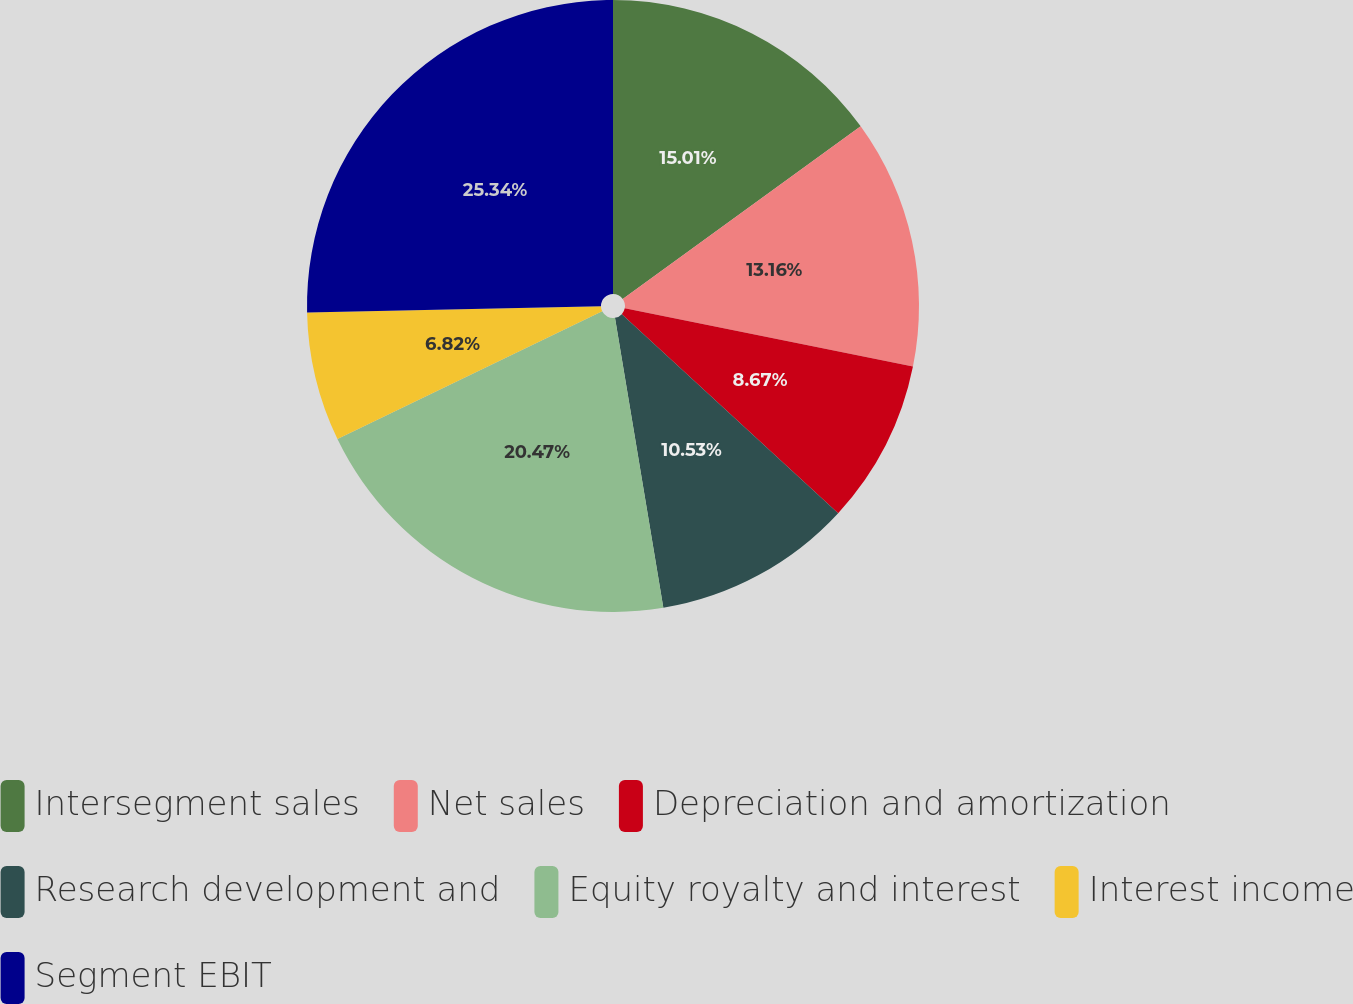Convert chart to OTSL. <chart><loc_0><loc_0><loc_500><loc_500><pie_chart><fcel>Intersegment sales<fcel>Net sales<fcel>Depreciation and amortization<fcel>Research development and<fcel>Equity royalty and interest<fcel>Interest income<fcel>Segment EBIT<nl><fcel>15.01%<fcel>13.16%<fcel>8.67%<fcel>10.53%<fcel>20.47%<fcel>6.82%<fcel>25.34%<nl></chart> 